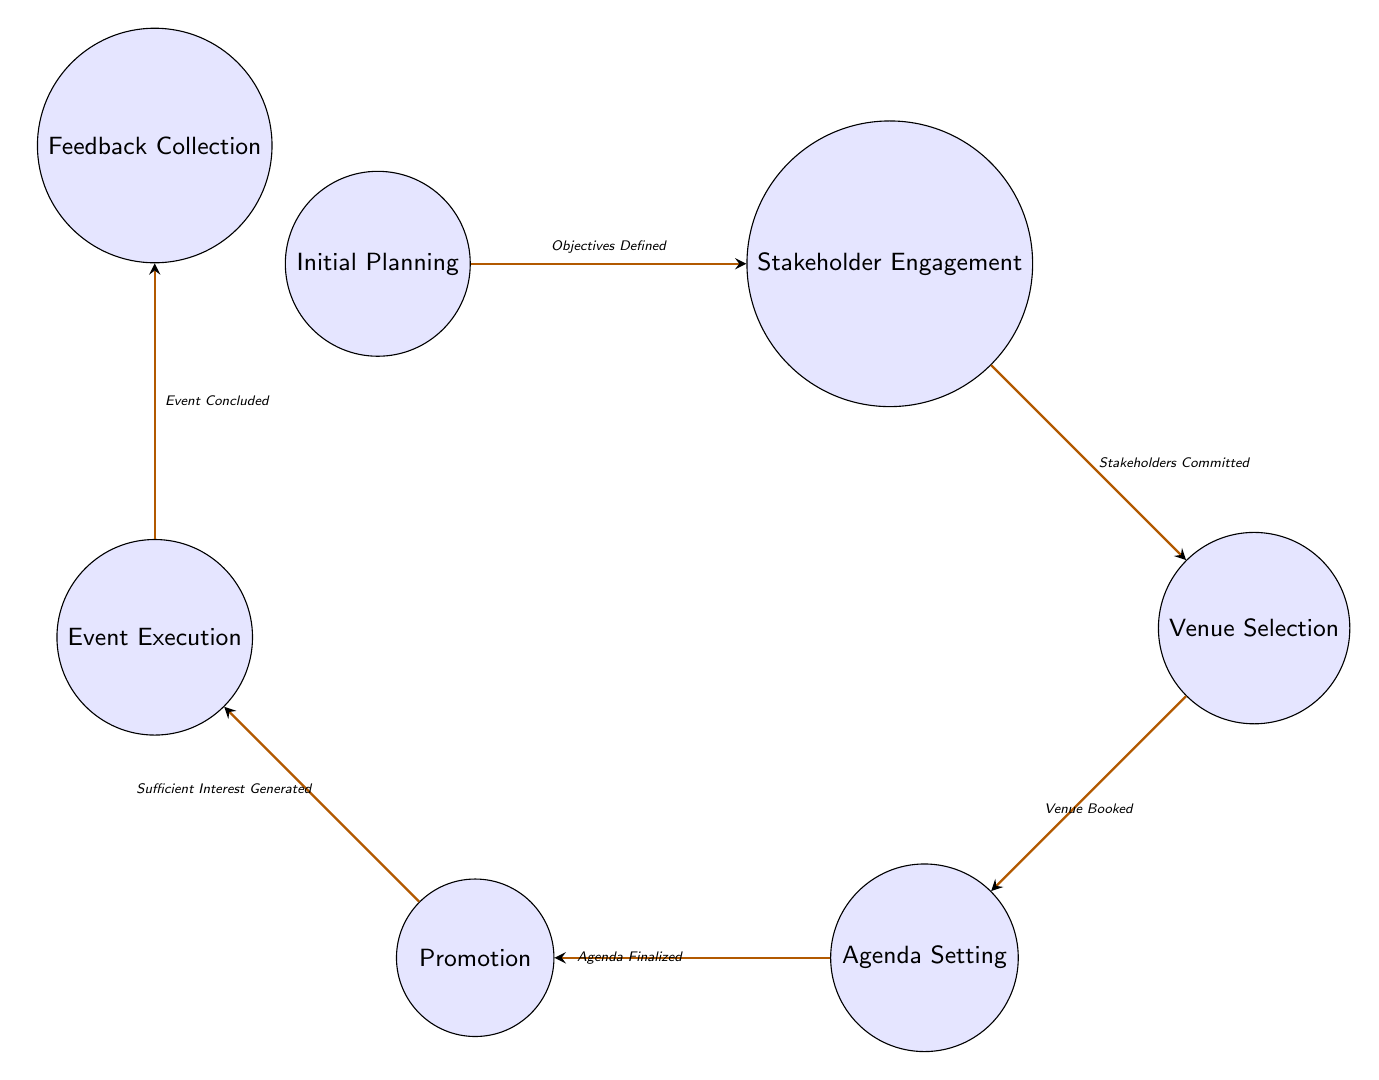What is the first state in the diagram? The diagram starts with the state labeled "Initial Planning," which is the first node shown in the sequence.
Answer: Initial Planning How many states are there in total? By counting the listed states in the diagram, including Initial Planning, Stakeholder Engagement, Venue Selection, Agenda Setting, Promotion, Event Execution, and Feedback Collection, there are a total of seven states.
Answer: Seven What is the transition that occurs after "Stakeholder Engagement"? The transition from "Stakeholder Engagement" leads to "Venue Selection" and is triggered when stakeholders are committed.
Answer: Venue Selection What triggers the transition from "Venue Selection" to "Agenda Setting"? The transition occurs when the venue is booked, indicating readiness to move to the next phase of planning the event.
Answer: Venue Booked What state occurs after "Promotion"? Following "Promotion," the transition leads to "Event Execution," which signifies the execution phase of the event planning process.
Answer: Event Execution How many transitions are shown in the diagram? The diagram displays six transitions, connecting the various states in the interfaith dialogue planning process.
Answer: Six What are the last two states in the flow of the diagram? The last two states in the flow, as seen in the sequence, are "Event Execution" followed by "Feedback Collection."
Answer: Event Execution and Feedback Collection Which state requires objectives to be defined as a trigger for transition? The state "Stakeholder Engagement" requires the trigger of objectives being defined to transition from the initial planning state.
Answer: Stakeholder Engagement What does the transition from "Event Execution" lead to? The transition from "Event Execution" leads to the "Feedback Collection" state, which is the final step in assessing the event's effectiveness.
Answer: Feedback Collection 